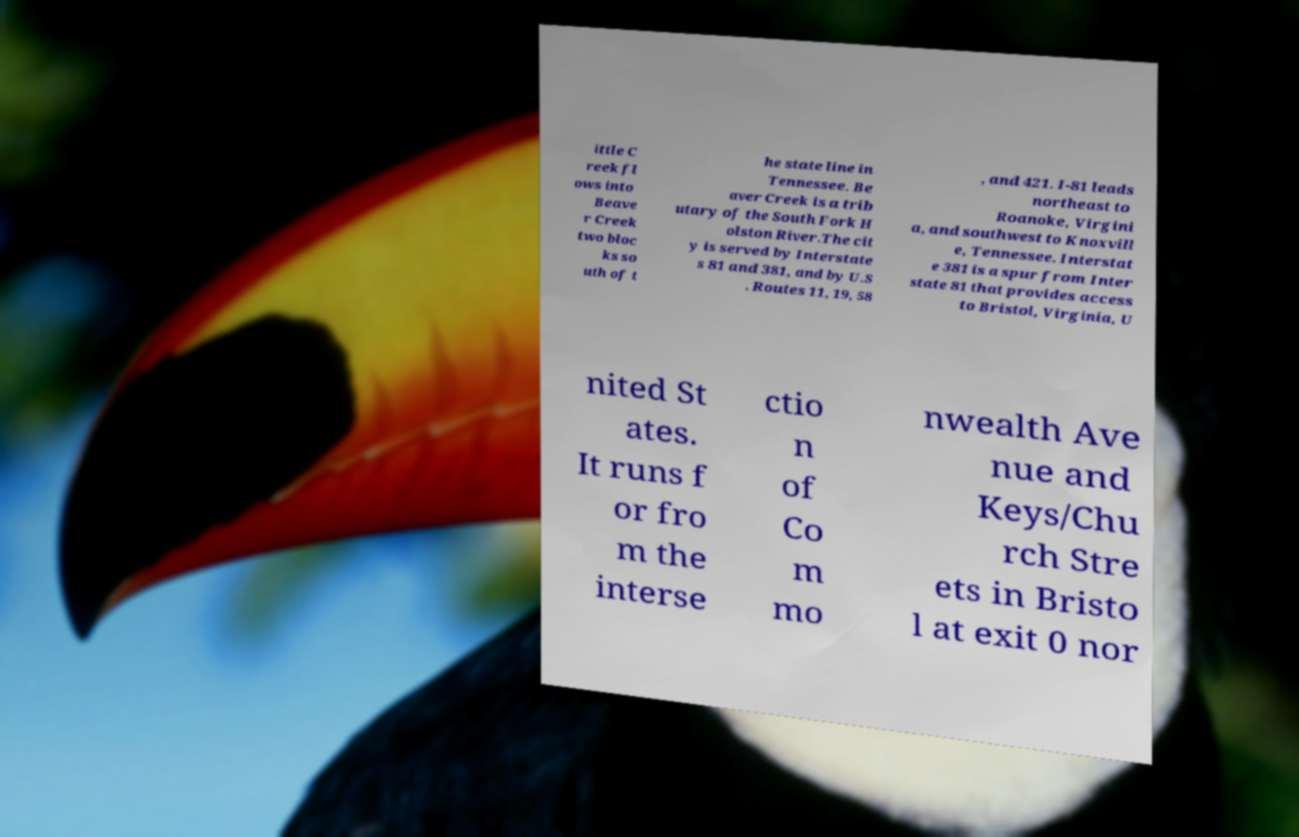Could you extract and type out the text from this image? ittle C reek fl ows into Beave r Creek two bloc ks so uth of t he state line in Tennessee. Be aver Creek is a trib utary of the South Fork H olston River.The cit y is served by Interstate s 81 and 381, and by U.S . Routes 11, 19, 58 , and 421. I-81 leads northeast to Roanoke, Virgini a, and southwest to Knoxvill e, Tennessee. Interstat e 381 is a spur from Inter state 81 that provides access to Bristol, Virginia, U nited St ates. It runs f or fro m the interse ctio n of Co m mo nwealth Ave nue and Keys/Chu rch Stre ets in Bristo l at exit 0 nor 